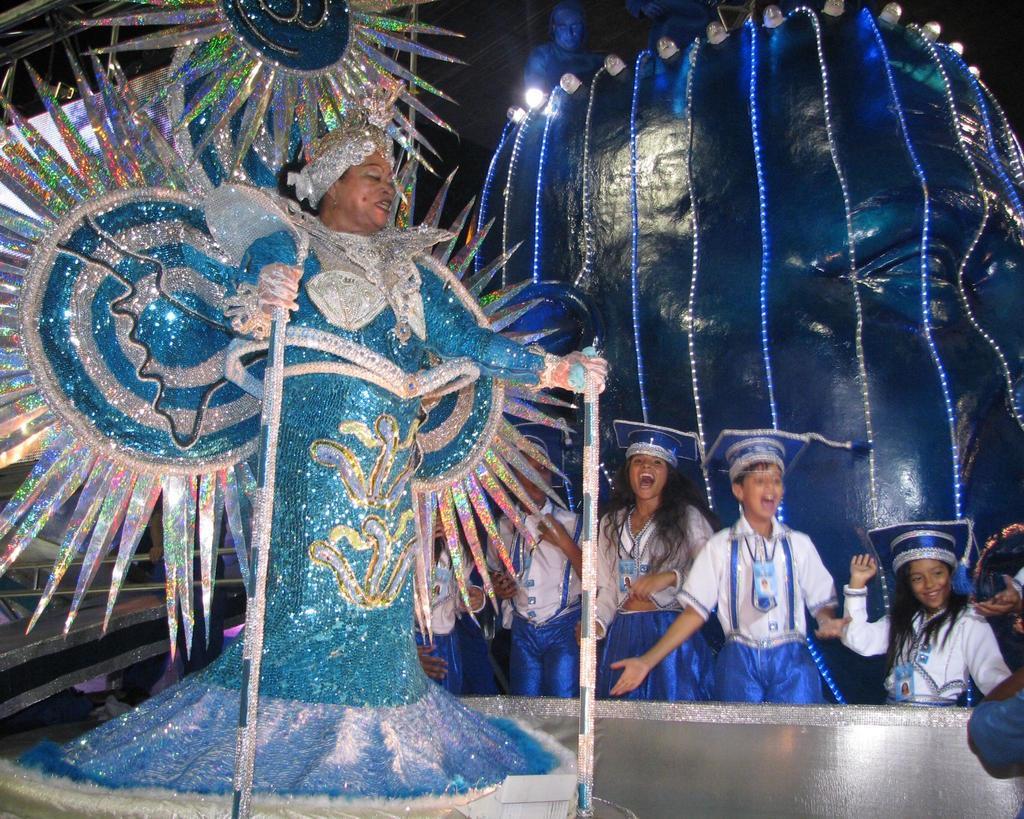How would you summarize this image in a sentence or two? In this image I can see a woman wearing a colorful design dress and holding sticks standing on stage and back side of the stage I can see children's and I can see the wall and on the top of the wall I can see person 